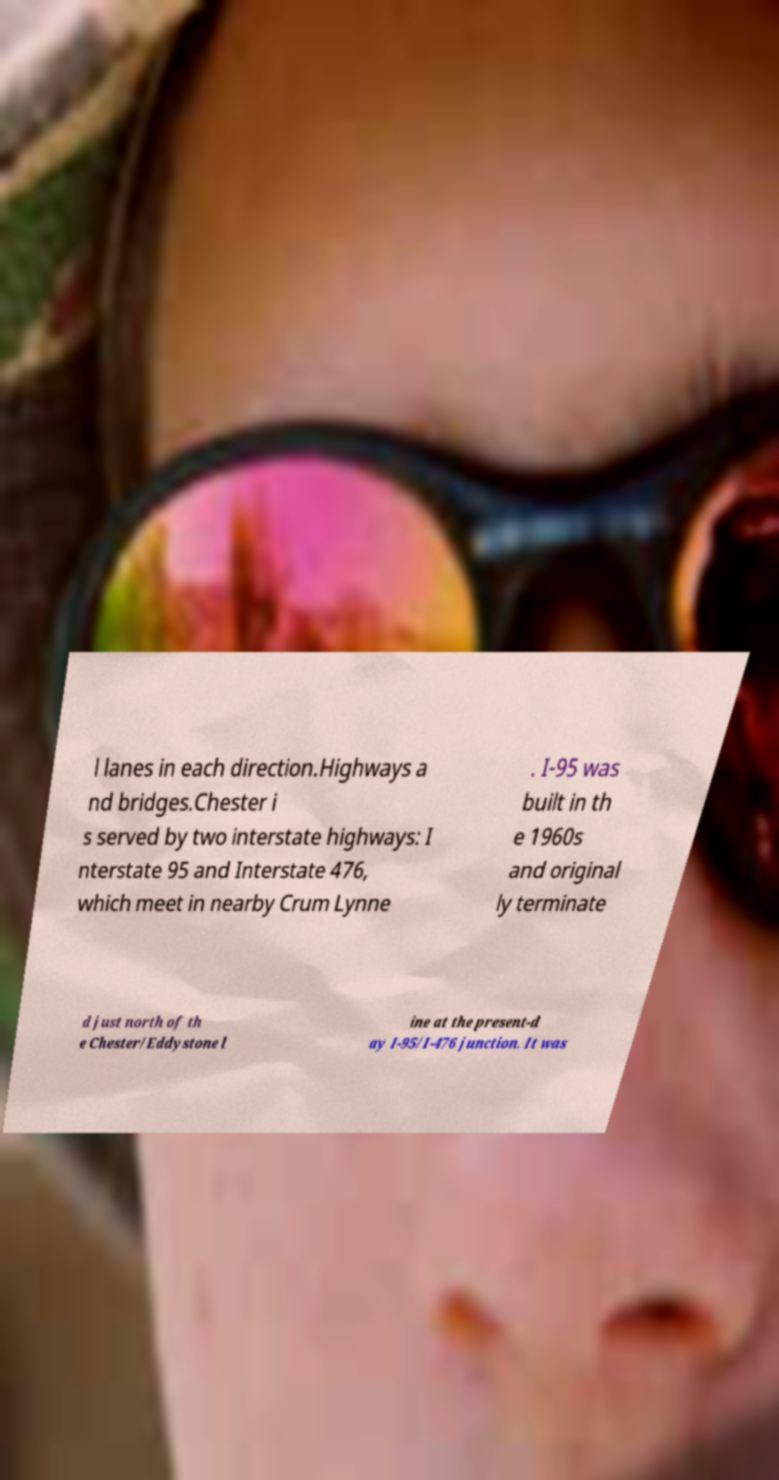Could you extract and type out the text from this image? l lanes in each direction.Highways a nd bridges.Chester i s served by two interstate highways: I nterstate 95 and Interstate 476, which meet in nearby Crum Lynne . I-95 was built in th e 1960s and original ly terminate d just north of th e Chester/Eddystone l ine at the present-d ay I-95/I-476 junction. It was 